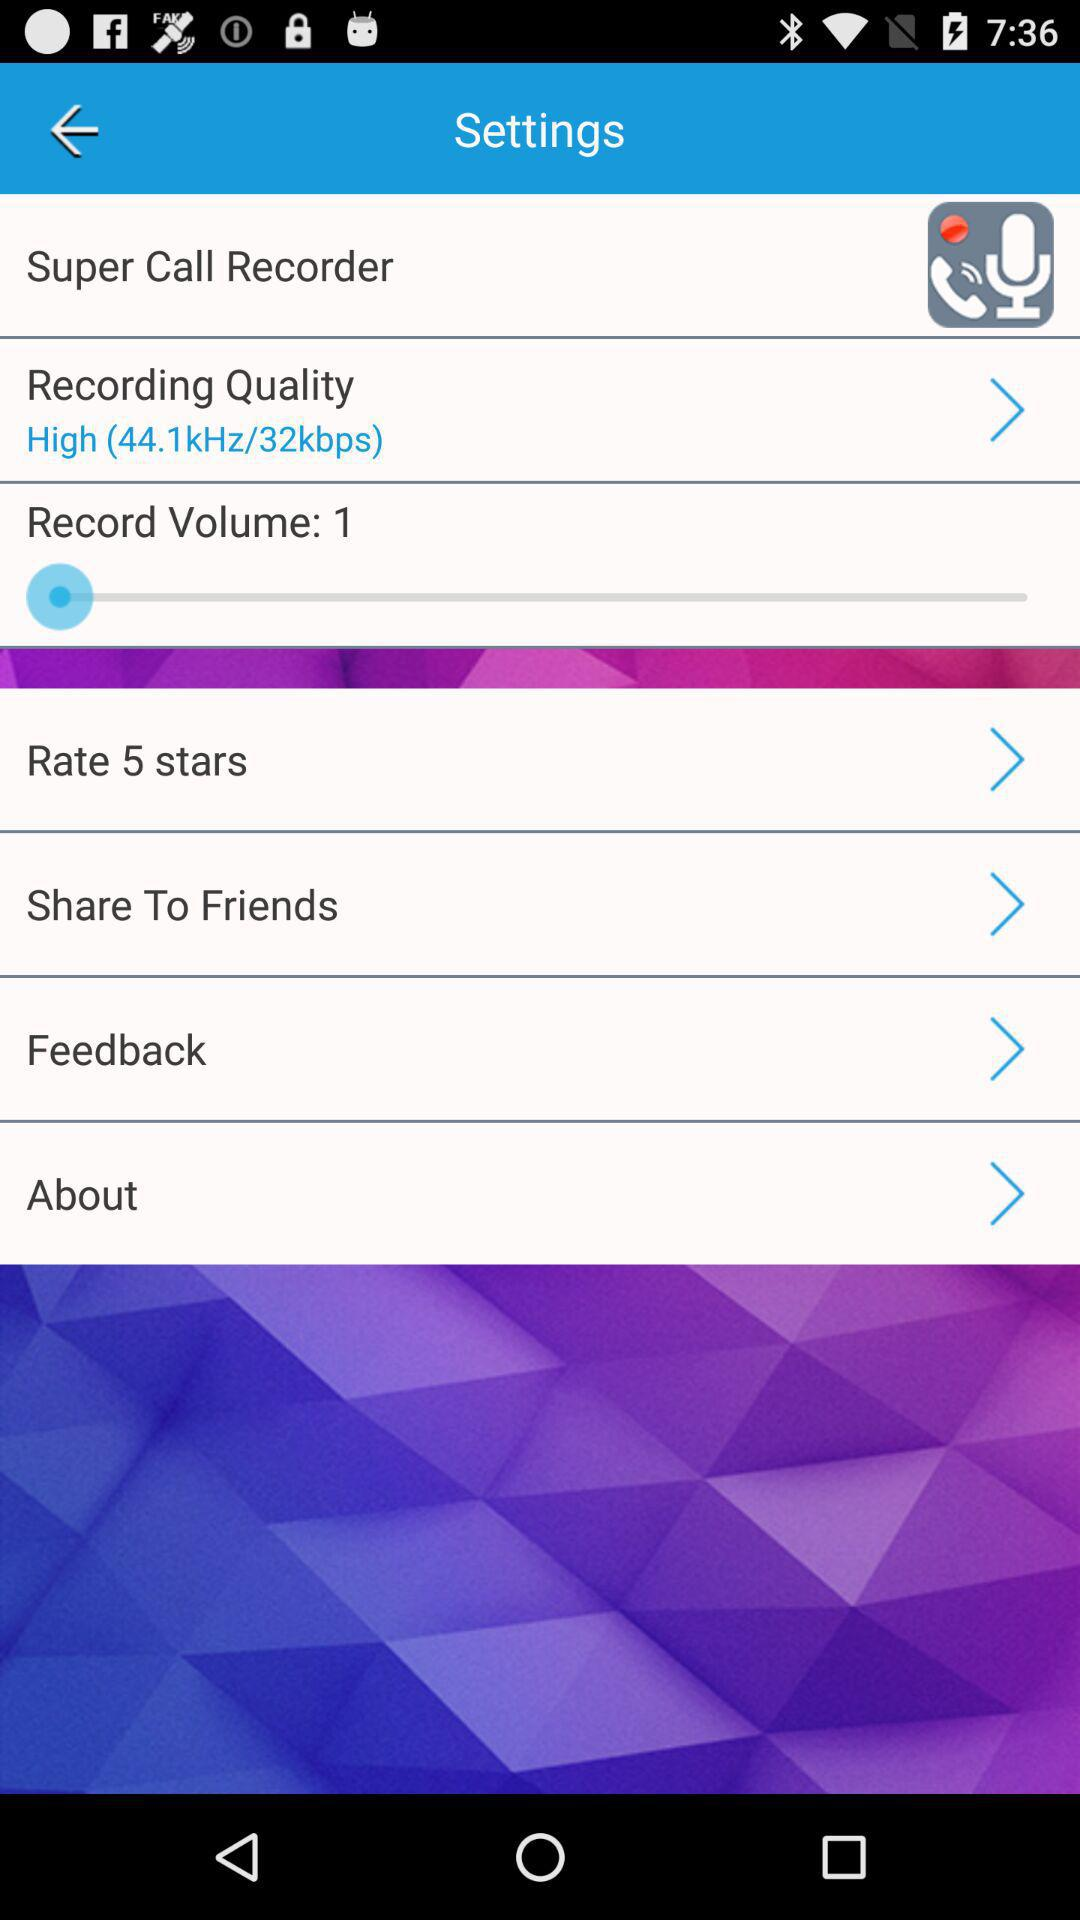What is the recording quality? The recording quality is high (44.1kHz/32kbps). 